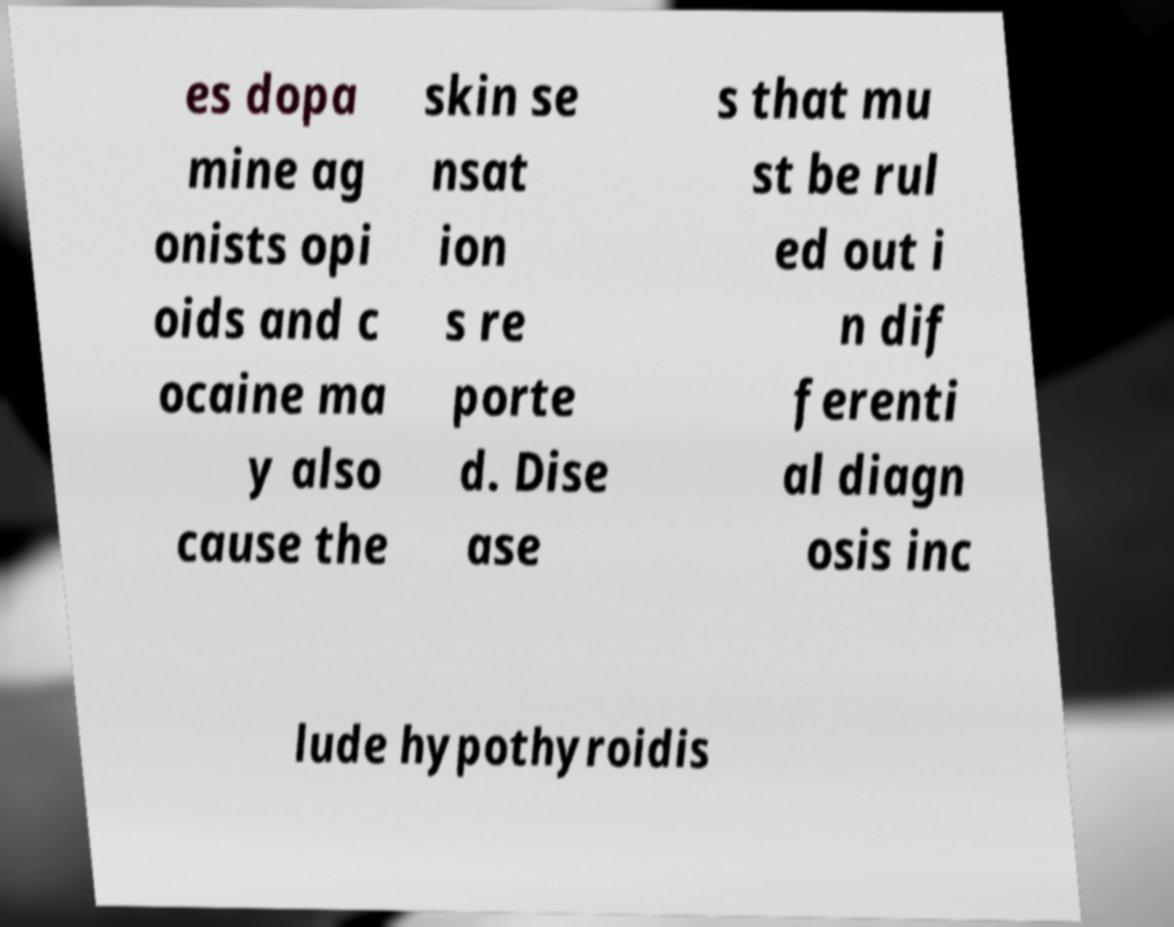What messages or text are displayed in this image? I need them in a readable, typed format. es dopa mine ag onists opi oids and c ocaine ma y also cause the skin se nsat ion s re porte d. Dise ase s that mu st be rul ed out i n dif ferenti al diagn osis inc lude hypothyroidis 